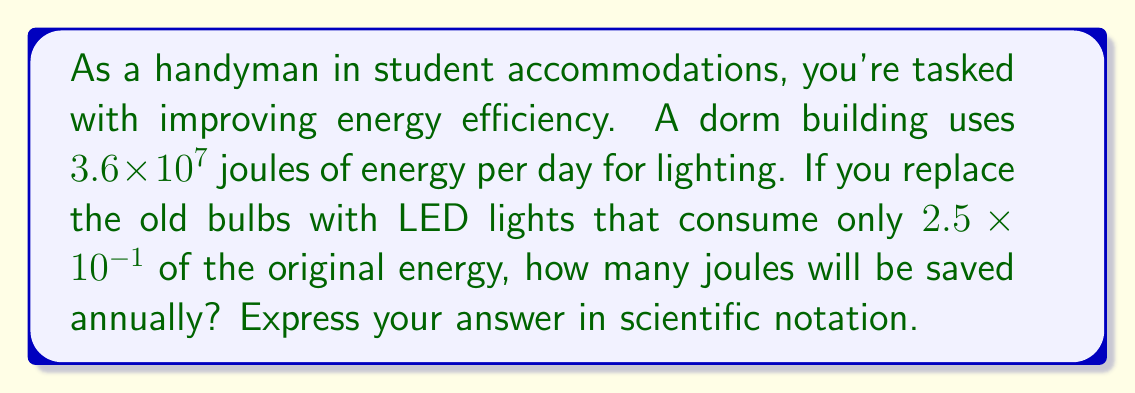Can you answer this question? Let's break this down step by step:

1) First, let's calculate the new daily energy consumption with LED lights:
   $$(3.6 \times 10^7) \times (2.5 \times 10^{-1}) = 9 \times 10^6$$ joules per day

2) Now, let's calculate the daily energy savings:
   $$3.6 \times 10^7 - 9 \times 10^6 = 2.7 \times 10^7$$ joules per day

3) To find the annual savings, we multiply by the number of days in a year:
   $$(2.7 \times 10^7) \times 365 = 9.855 \times 10^9$$ joules per year

4) Rounding to 3 significant figures and expressing in scientific notation:
   $$9.86 \times 10^9$$ joules per year
Answer: $9.86 \times 10^9$ joules 